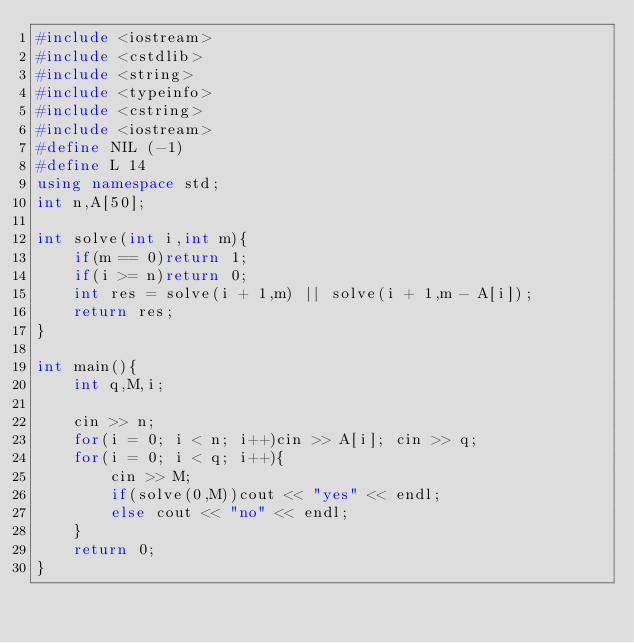Convert code to text. <code><loc_0><loc_0><loc_500><loc_500><_C++_>#include <iostream>
#include <cstdlib>
#include <string>
#include <typeinfo>
#include <cstring>
#include <iostream>
#define NIL (-1)
#define L 14
using namespace std;
int n,A[50];

int solve(int i,int m){
    if(m == 0)return 1;
    if(i >= n)return 0;
    int res = solve(i + 1,m) || solve(i + 1,m - A[i]);
    return res;
}

int main(){
    int q,M,i;
    
    cin >> n;
    for(i = 0; i < n; i++)cin >> A[i]; cin >> q;
    for(i = 0; i < q; i++){
        cin >> M;
        if(solve(0,M))cout << "yes" << endl;
        else cout << "no" << endl;
    }
    return 0;
}
</code> 